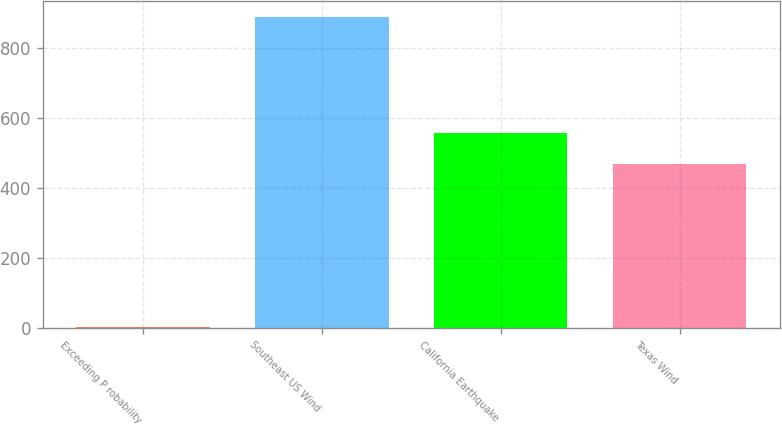<chart> <loc_0><loc_0><loc_500><loc_500><bar_chart><fcel>Exceeding P robability<fcel>Southeast US Wind<fcel>California Earthquake<fcel>Texas Wind<nl><fcel>2<fcel>888<fcel>555.6<fcel>467<nl></chart> 